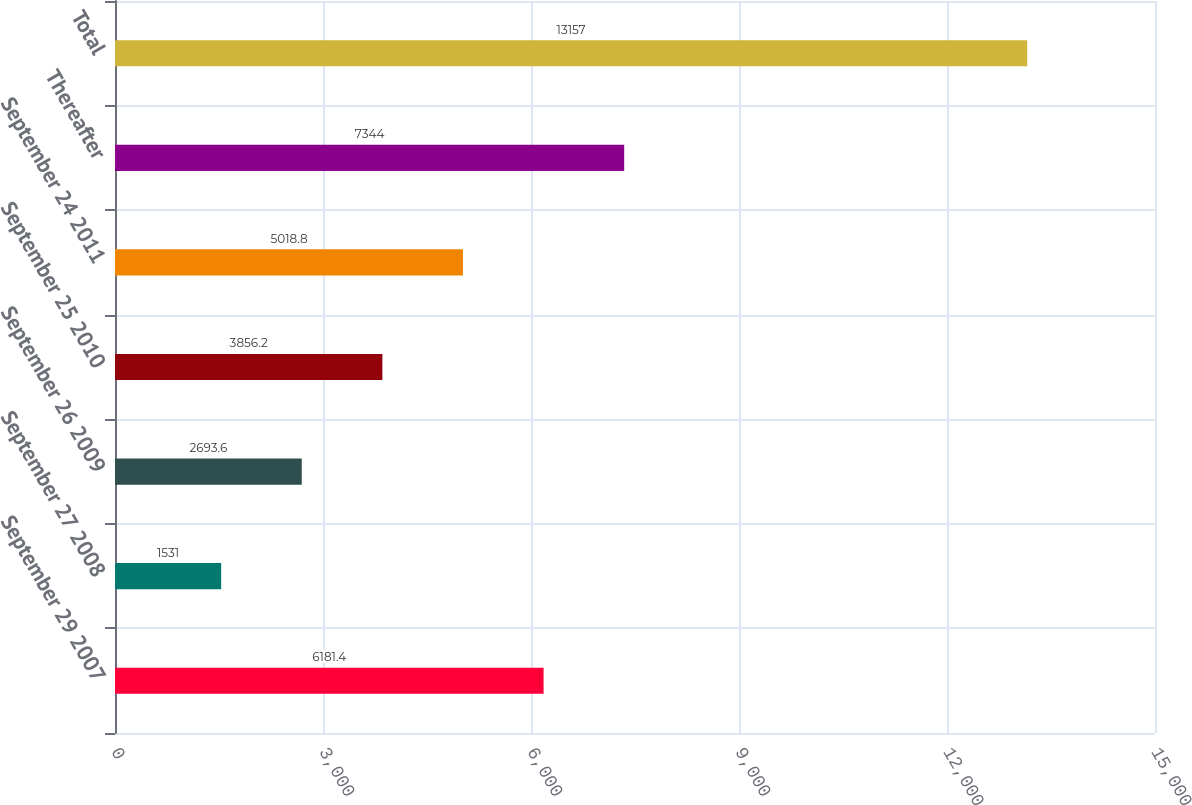Convert chart. <chart><loc_0><loc_0><loc_500><loc_500><bar_chart><fcel>September 29 2007<fcel>September 27 2008<fcel>September 26 2009<fcel>September 25 2010<fcel>September 24 2011<fcel>Thereafter<fcel>Total<nl><fcel>6181.4<fcel>1531<fcel>2693.6<fcel>3856.2<fcel>5018.8<fcel>7344<fcel>13157<nl></chart> 